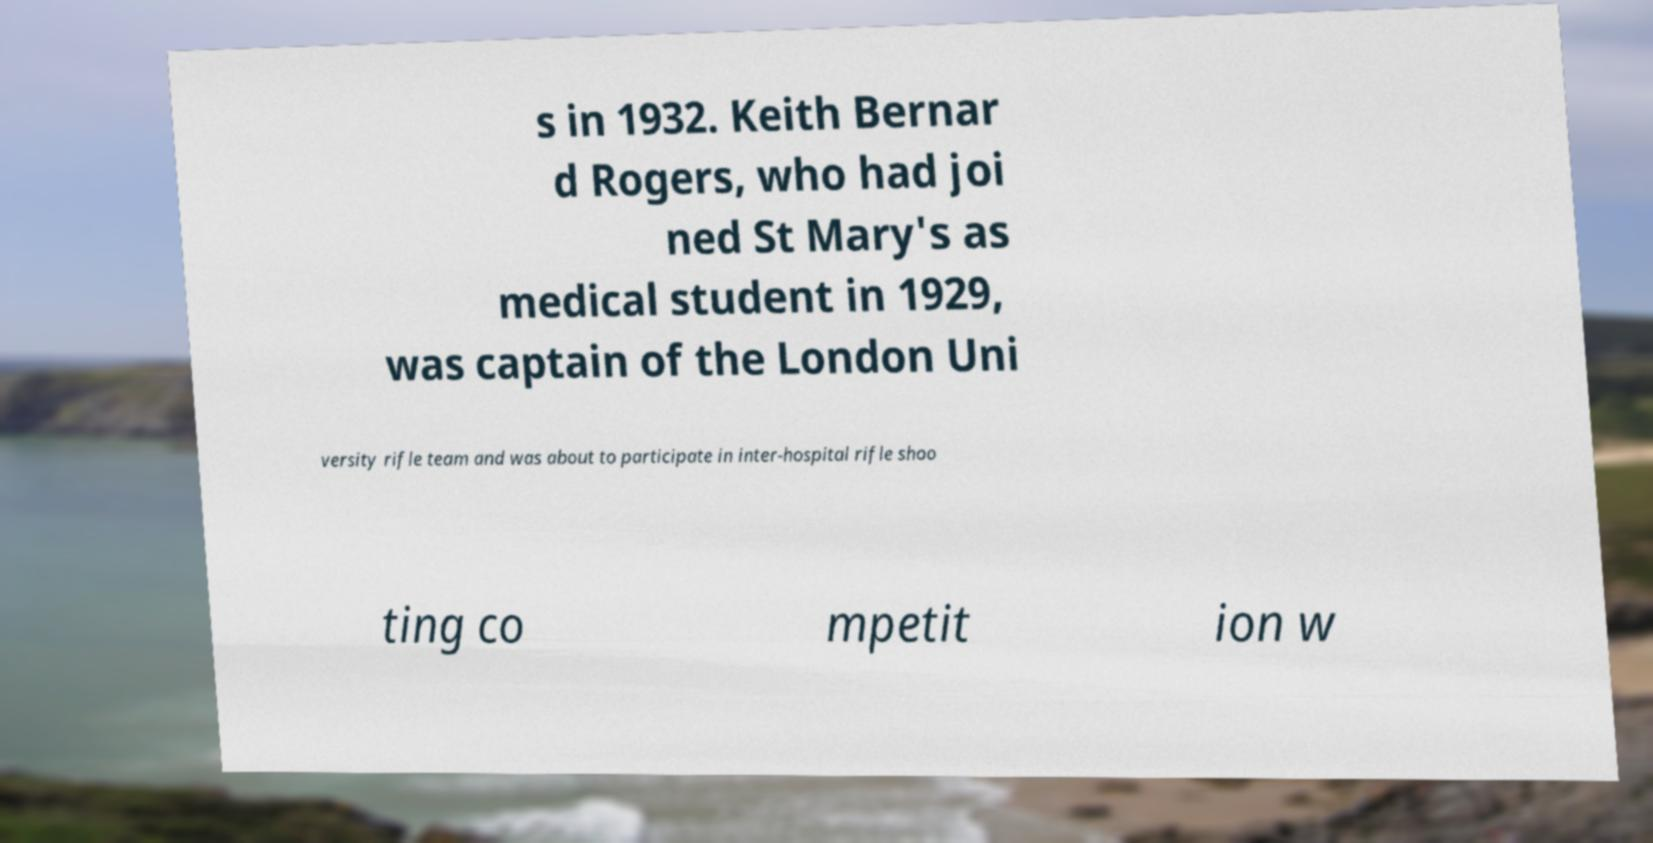What messages or text are displayed in this image? I need them in a readable, typed format. s in 1932. Keith Bernar d Rogers, who had joi ned St Mary's as medical student in 1929, was captain of the London Uni versity rifle team and was about to participate in inter-hospital rifle shoo ting co mpetit ion w 